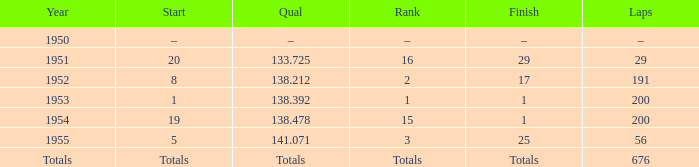How many rounds does the one positioned 16 have? 29.0. 